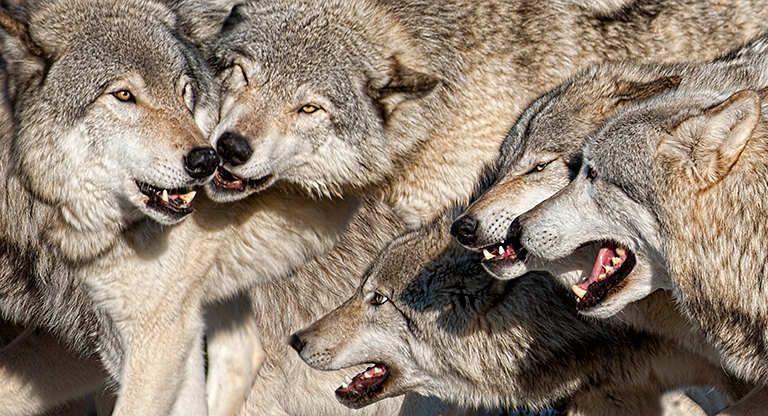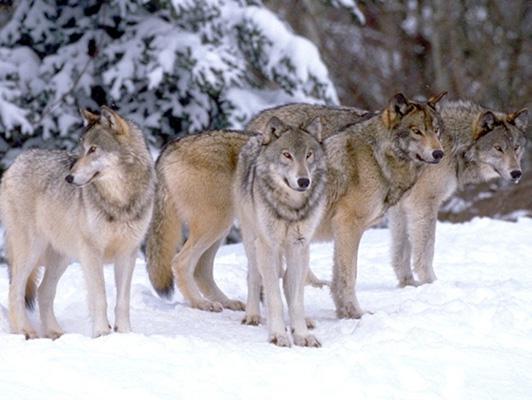The first image is the image on the left, the second image is the image on the right. For the images shown, is this caption "There is no more than two wolves in the left image." true? Answer yes or no. No. 